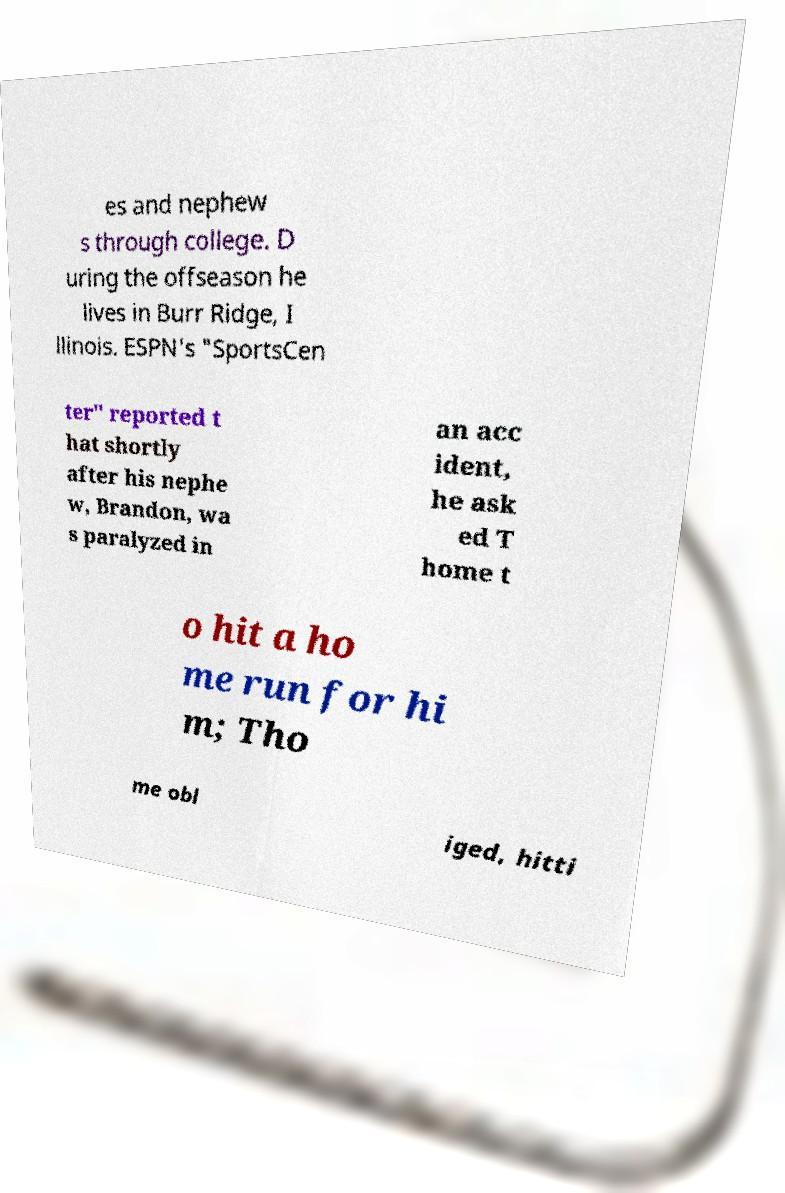Please read and relay the text visible in this image. What does it say? es and nephew s through college. D uring the offseason he lives in Burr Ridge, I llinois. ESPN's "SportsCen ter" reported t hat shortly after his nephe w, Brandon, wa s paralyzed in an acc ident, he ask ed T home t o hit a ho me run for hi m; Tho me obl iged, hitti 